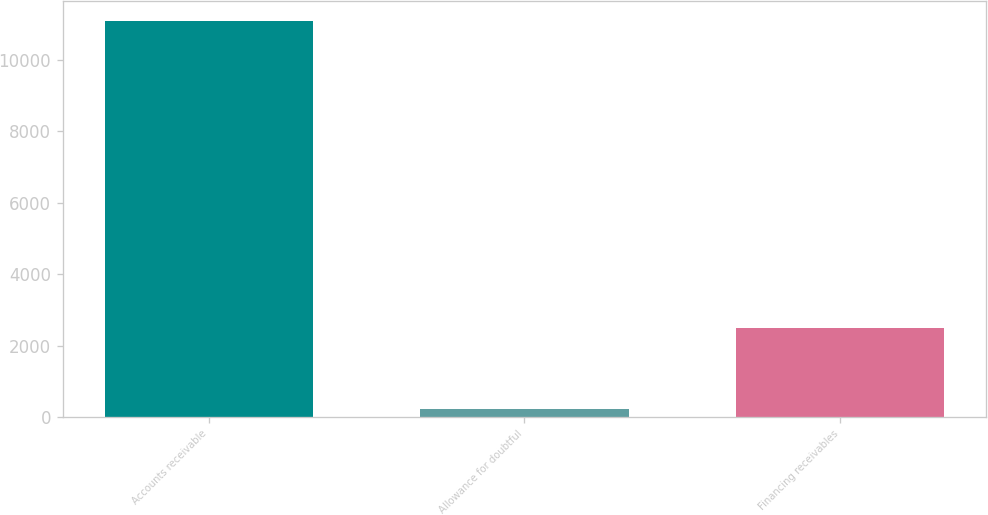Convert chart. <chart><loc_0><loc_0><loc_500><loc_500><bar_chart><fcel>Accounts receivable<fcel>Allowance for doubtful<fcel>Financing receivables<nl><fcel>11093<fcel>220<fcel>2480<nl></chart> 